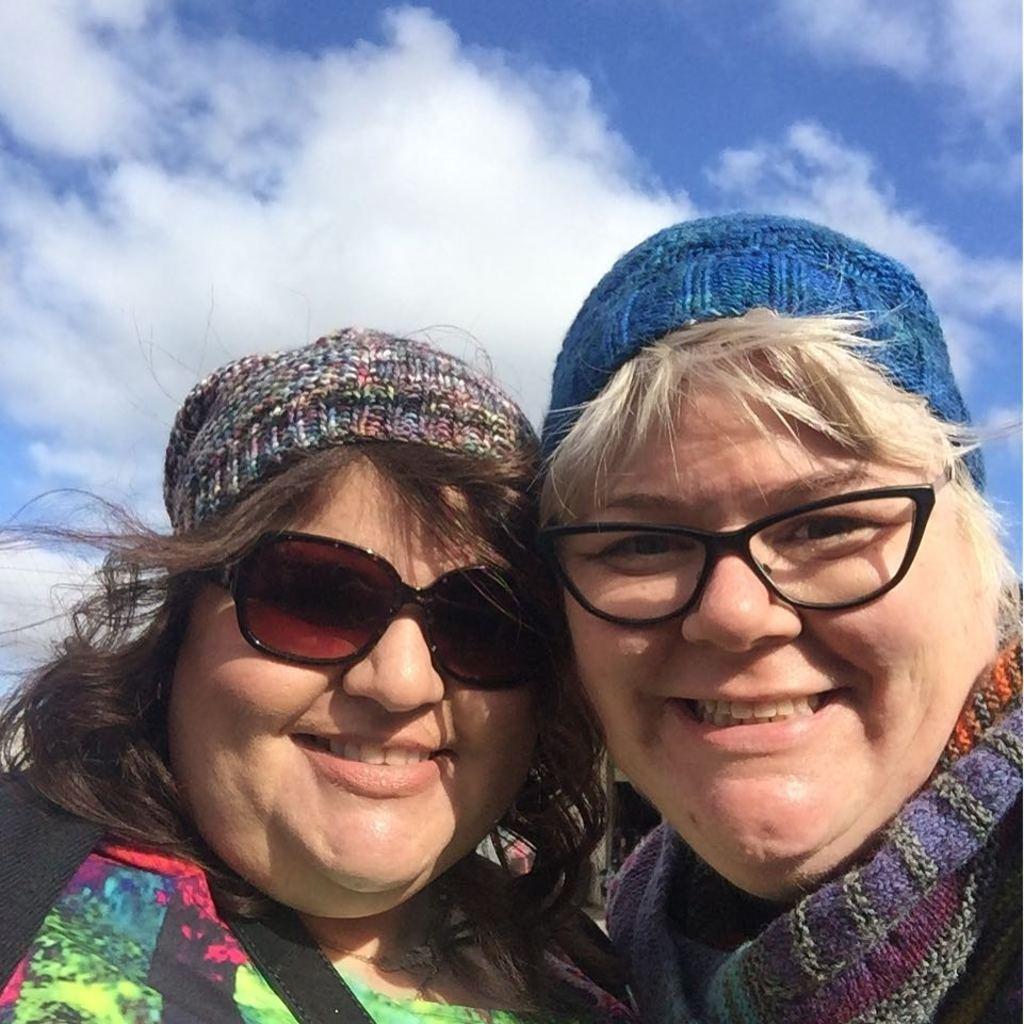Can you describe this image briefly? In this image we can see two women wearing glasses holding each other. On the backside we can see the sky which looks cloudy. 